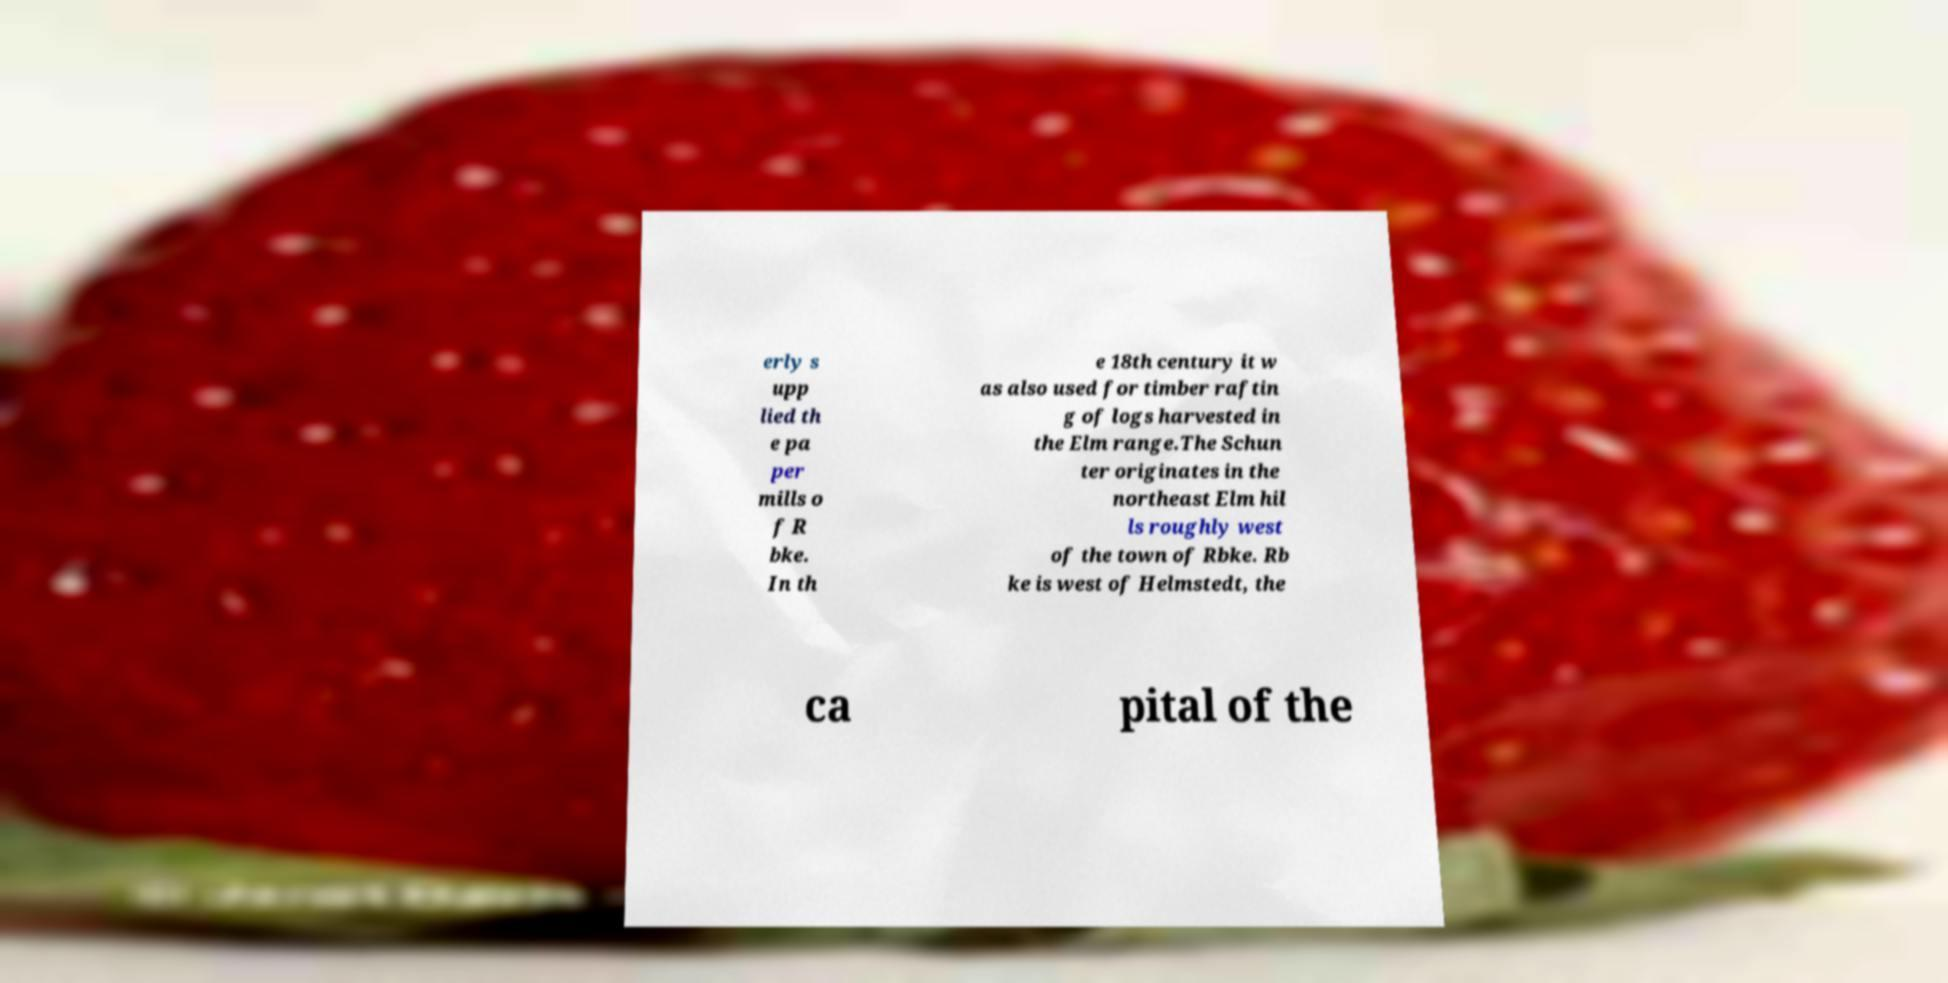Could you assist in decoding the text presented in this image and type it out clearly? erly s upp lied th e pa per mills o f R bke. In th e 18th century it w as also used for timber raftin g of logs harvested in the Elm range.The Schun ter originates in the northeast Elm hil ls roughly west of the town of Rbke. Rb ke is west of Helmstedt, the ca pital of the 